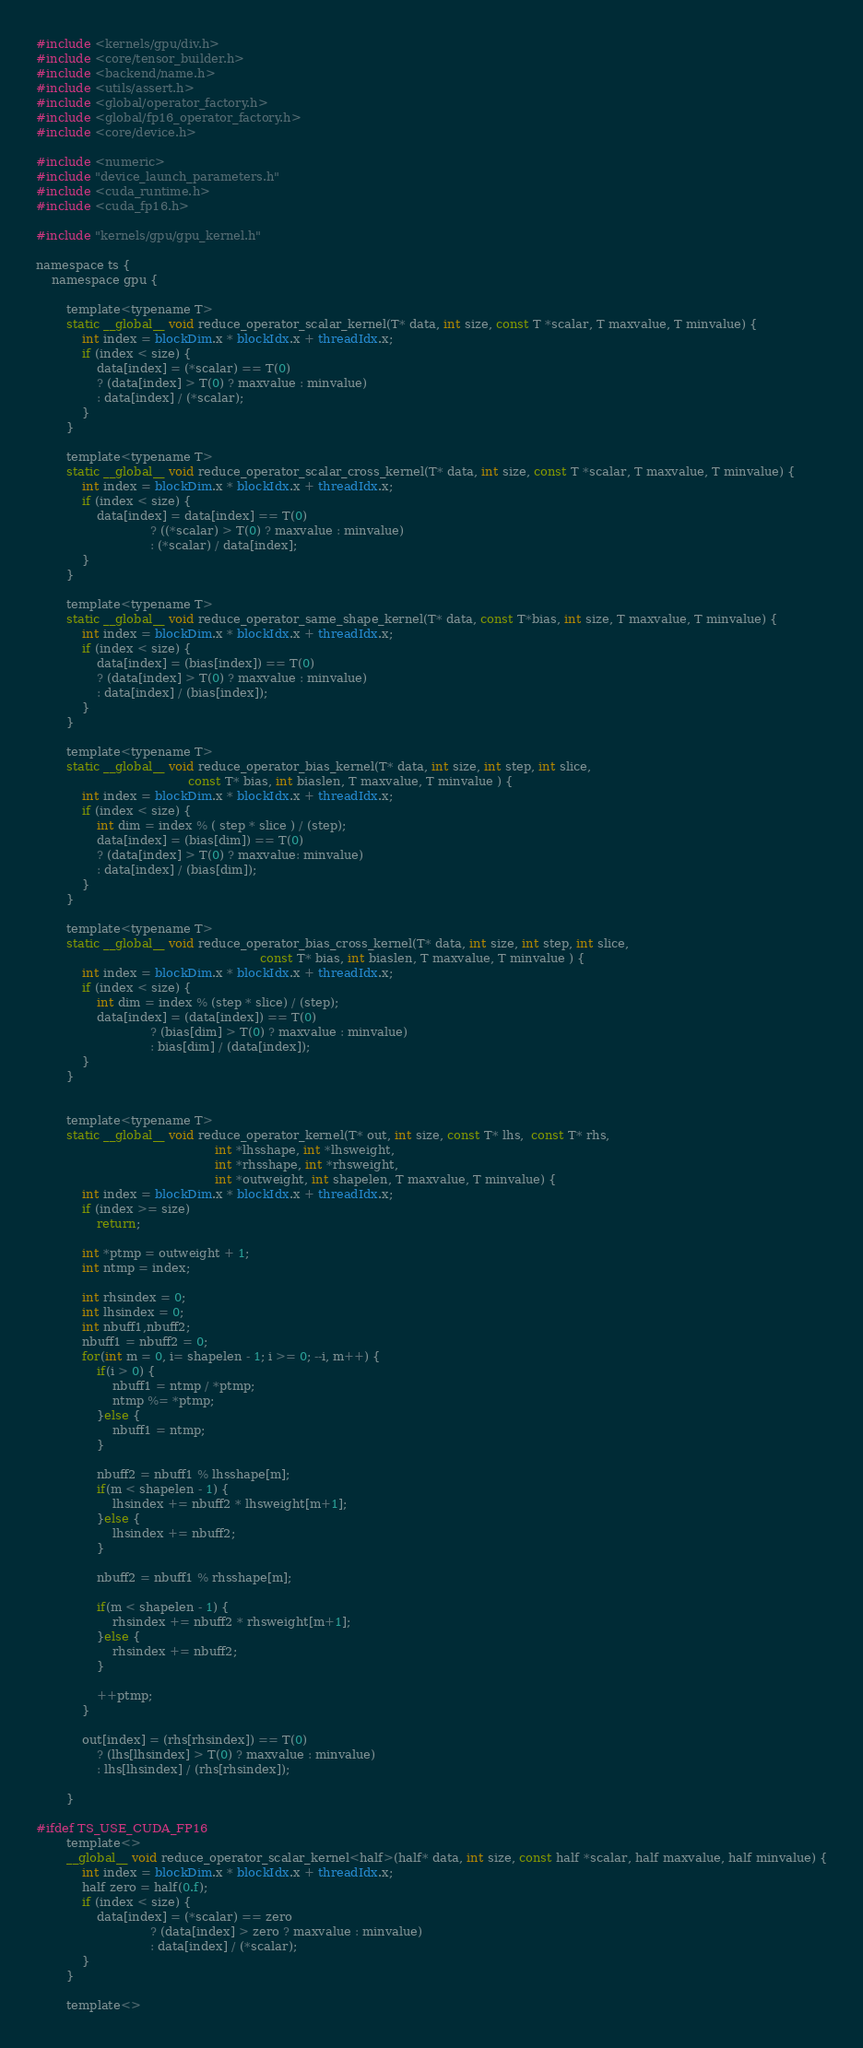Convert code to text. <code><loc_0><loc_0><loc_500><loc_500><_Cuda_>#include <kernels/gpu/div.h>
#include <core/tensor_builder.h>
#include <backend/name.h>
#include <utils/assert.h>
#include <global/operator_factory.h>
#include <global/fp16_operator_factory.h>
#include <core/device.h>

#include <numeric>
#include "device_launch_parameters.h"
#include <cuda_runtime.h>
#include <cuda_fp16.h>

#include "kernels/gpu/gpu_kernel.h"

namespace ts {
    namespace gpu {

        template<typename T>
        static __global__ void reduce_operator_scalar_kernel(T* data, int size, const T *scalar, T maxvalue, T minvalue) {
            int index = blockDim.x * blockIdx.x + threadIdx.x;
            if (index < size) {
                data[index] = (*scalar) == T(0)
                ? (data[index] > T(0) ? maxvalue : minvalue)
                : data[index] / (*scalar);
            }
        }

        template<typename T>
        static __global__ void reduce_operator_scalar_cross_kernel(T* data, int size, const T *scalar, T maxvalue, T minvalue) {
            int index = blockDim.x * blockIdx.x + threadIdx.x;
            if (index < size) {
                data[index] = data[index] == T(0)
                              ? ((*scalar) > T(0) ? maxvalue : minvalue)
                              : (*scalar) / data[index];
            }
        }

        template<typename T>
        static __global__ void reduce_operator_same_shape_kernel(T* data, const T*bias, int size, T maxvalue, T minvalue) {
            int index = blockDim.x * blockIdx.x + threadIdx.x;
            if (index < size) {
                data[index] = (bias[index]) == T(0)
                ? (data[index] > T(0) ? maxvalue : minvalue)
                : data[index] / (bias[index]);
            }
        }

        template<typename T>
        static __global__ void reduce_operator_bias_kernel(T* data, int size, int step, int slice,
                                        const T* bias, int biaslen, T maxvalue, T minvalue ) {
            int index = blockDim.x * blockIdx.x + threadIdx.x;
            if (index < size) {
                int dim = index % ( step * slice ) / (step);
                data[index] = (bias[dim]) == T(0)
                ? (data[index] > T(0) ? maxvalue: minvalue)
                : data[index] / (bias[dim]);
            }
        }

        template<typename T>
        static __global__ void reduce_operator_bias_cross_kernel(T* data, int size, int step, int slice,
                                                           const T* bias, int biaslen, T maxvalue, T minvalue ) {
            int index = blockDim.x * blockIdx.x + threadIdx.x;
            if (index < size) {
                int dim = index % (step * slice) / (step);
                data[index] = (data[index]) == T(0)
                              ? (bias[dim] > T(0) ? maxvalue : minvalue)
                              : bias[dim] / (data[index]);
            }
        }


        template<typename T>
        static __global__ void reduce_operator_kernel(T* out, int size, const T* lhs,  const T* rhs,
                                               int *lhsshape, int *lhsweight,
                                               int *rhsshape, int *rhsweight,
                                               int *outweight, int shapelen, T maxvalue, T minvalue) {
            int index = blockDim.x * blockIdx.x + threadIdx.x;
            if (index >= size)
                return;

            int *ptmp = outweight + 1;
            int ntmp = index;

            int rhsindex = 0;
            int lhsindex = 0;
            int nbuff1,nbuff2;
            nbuff1 = nbuff2 = 0;
            for(int m = 0, i= shapelen - 1; i >= 0; --i, m++) {
                if(i > 0) {
                    nbuff1 = ntmp / *ptmp;
                    ntmp %= *ptmp;
                }else {
                    nbuff1 = ntmp;
                }

                nbuff2 = nbuff1 % lhsshape[m];
                if(m < shapelen - 1) {
                    lhsindex += nbuff2 * lhsweight[m+1];
                }else {
                    lhsindex += nbuff2;
                }

                nbuff2 = nbuff1 % rhsshape[m];

                if(m < shapelen - 1) {
                    rhsindex += nbuff2 * rhsweight[m+1];
                }else {
                    rhsindex += nbuff2;
                }

                ++ptmp;
            }

            out[index] = (rhs[rhsindex]) == T(0)
                ? (lhs[lhsindex] > T(0) ? maxvalue : minvalue)
                : lhs[lhsindex] / (rhs[rhsindex]);

        }

#ifdef TS_USE_CUDA_FP16
        template<>
        __global__ void reduce_operator_scalar_kernel<half>(half* data, int size, const half *scalar, half maxvalue, half minvalue) {
            int index = blockDim.x * blockIdx.x + threadIdx.x;
            half zero = half(0.f);
            if (index < size) {
                data[index] = (*scalar) == zero
                              ? (data[index] > zero ? maxvalue : minvalue)
                              : data[index] / (*scalar);
            }
        }

        template<></code> 